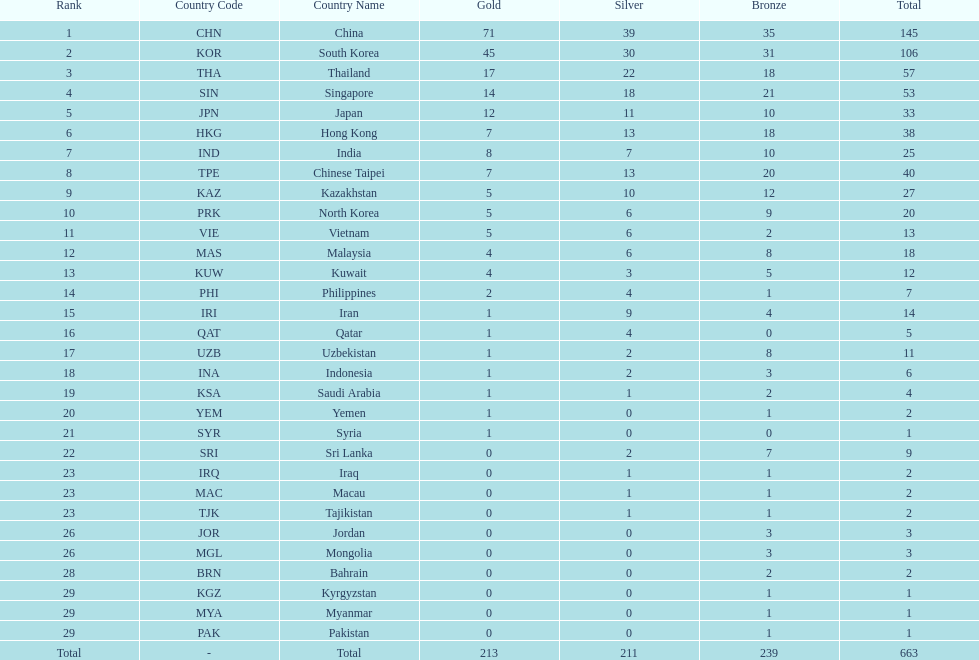What is the total number of medals that india won in the asian youth games? 25. Would you be able to parse every entry in this table? {'header': ['Rank', 'Country Code', 'Country Name', 'Gold', 'Silver', 'Bronze', 'Total'], 'rows': [['1', 'CHN', 'China', '71', '39', '35', '145'], ['2', 'KOR', 'South Korea', '45', '30', '31', '106'], ['3', 'THA', 'Thailand', '17', '22', '18', '57'], ['4', 'SIN', 'Singapore', '14', '18', '21', '53'], ['5', 'JPN', 'Japan', '12', '11', '10', '33'], ['6', 'HKG', 'Hong Kong', '7', '13', '18', '38'], ['7', 'IND', 'India', '8', '7', '10', '25'], ['8', 'TPE', 'Chinese Taipei', '7', '13', '20', '40'], ['9', 'KAZ', 'Kazakhstan', '5', '10', '12', '27'], ['10', 'PRK', 'North Korea', '5', '6', '9', '20'], ['11', 'VIE', 'Vietnam', '5', '6', '2', '13'], ['12', 'MAS', 'Malaysia', '4', '6', '8', '18'], ['13', 'KUW', 'Kuwait', '4', '3', '5', '12'], ['14', 'PHI', 'Philippines', '2', '4', '1', '7'], ['15', 'IRI', 'Iran', '1', '9', '4', '14'], ['16', 'QAT', 'Qatar', '1', '4', '0', '5'], ['17', 'UZB', 'Uzbekistan', '1', '2', '8', '11'], ['18', 'INA', 'Indonesia', '1', '2', '3', '6'], ['19', 'KSA', 'Saudi Arabia', '1', '1', '2', '4'], ['20', 'YEM', 'Yemen', '1', '0', '1', '2'], ['21', 'SYR', 'Syria', '1', '0', '0', '1'], ['22', 'SRI', 'Sri Lanka', '0', '2', '7', '9'], ['23', 'IRQ', 'Iraq', '0', '1', '1', '2'], ['23', 'MAC', 'Macau', '0', '1', '1', '2'], ['23', 'TJK', 'Tajikistan', '0', '1', '1', '2'], ['26', 'JOR', 'Jordan', '0', '0', '3', '3'], ['26', 'MGL', 'Mongolia', '0', '0', '3', '3'], ['28', 'BRN', 'Bahrain', '0', '0', '2', '2'], ['29', 'KGZ', 'Kyrgyzstan', '0', '0', '1', '1'], ['29', 'MYA', 'Myanmar', '0', '0', '1', '1'], ['29', 'PAK', 'Pakistan', '0', '0', '1', '1'], ['Total', '-', 'Total', '213', '211', '239', '663']]} 